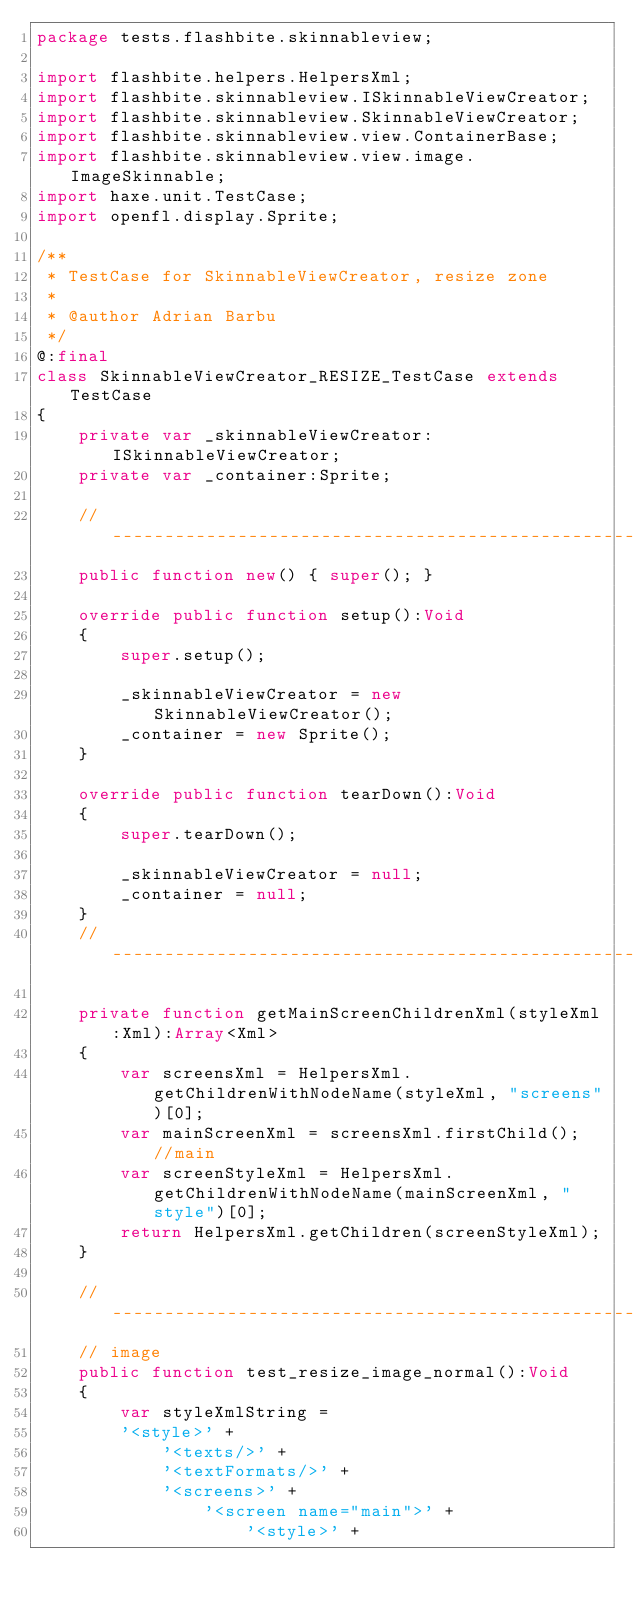<code> <loc_0><loc_0><loc_500><loc_500><_Haxe_>package tests.flashbite.skinnableview;

import flashbite.helpers.HelpersXml;
import flashbite.skinnableview.ISkinnableViewCreator;
import flashbite.skinnableview.SkinnableViewCreator;
import flashbite.skinnableview.view.ContainerBase;
import flashbite.skinnableview.view.image.ImageSkinnable;
import haxe.unit.TestCase;
import openfl.display.Sprite;

/**
 * TestCase for SkinnableViewCreator, resize zone
 * 
 * @author Adrian Barbu
 */
@:final
class SkinnableViewCreator_RESIZE_TestCase extends TestCase
{
	private var _skinnableViewCreator:ISkinnableViewCreator;
	private var _container:Sprite;
	
	// ------------------------------------------------------------------------------------------------------------------------------------
	public function new() { super(); }
	
	override public function setup():Void
	{
		super.setup();
		
		_skinnableViewCreator = new SkinnableViewCreator();
		_container = new Sprite();
	}
	
	override public function tearDown():Void
	{
		super.tearDown();
		
		_skinnableViewCreator = null;
		_container = null;
	}
	// ------------------------------------------------------------------------------------------------------------------------------------
	
	private function getMainScreenChildrenXml(styleXml:Xml):Array<Xml>
	{
		var screensXml = HelpersXml.getChildrenWithNodeName(styleXml, "screens")[0];
		var mainScreenXml = screensXml.firstChild(); //main
		var screenStyleXml = HelpersXml.getChildrenWithNodeName(mainScreenXml, "style")[0];
		return HelpersXml.getChildren(screenStyleXml);
	}
	
	// ------------------------------------------------------------------------------------------------------------------------------------
	// image
	public function test_resize_image_normal():Void
	{
		var styleXmlString = 
		'<style>' +
			'<texts/>' +
			'<textFormats/>' +
			'<screens>' +
				'<screen name="main">' +
					'<style>' +</code> 